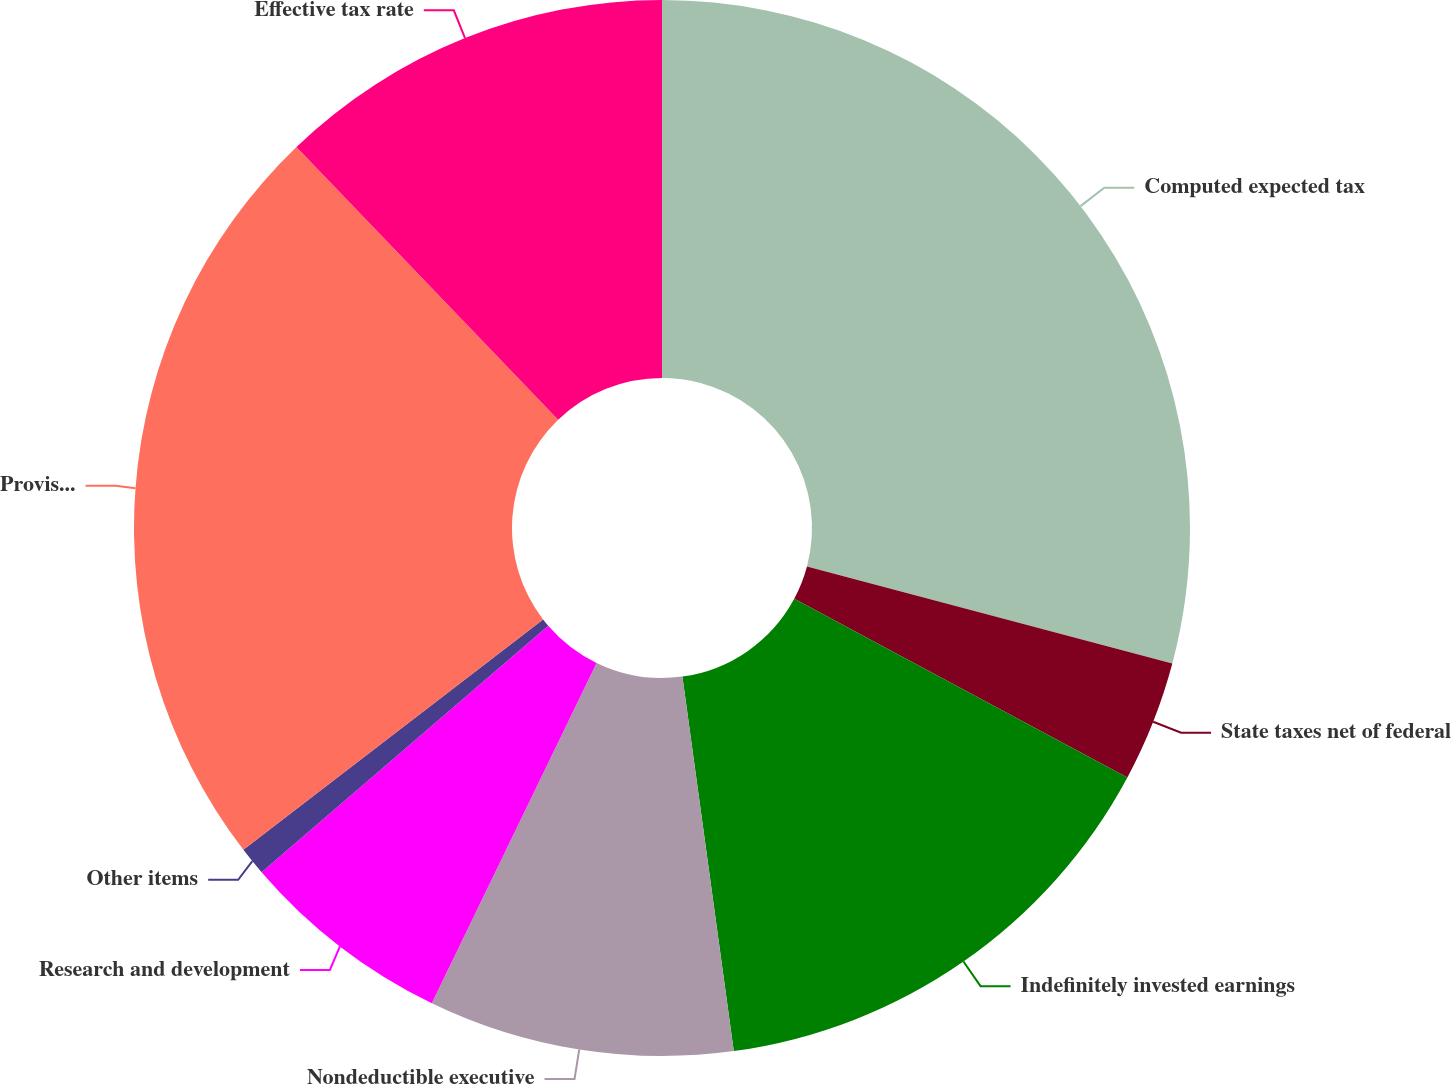Convert chart to OTSL. <chart><loc_0><loc_0><loc_500><loc_500><pie_chart><fcel>Computed expected tax<fcel>State taxes net of federal<fcel>Indefinitely invested earnings<fcel>Nondeductible executive<fcel>Research and development<fcel>Other items<fcel>Provision for income taxes<fcel>Effective tax rate<nl><fcel>29.13%<fcel>3.7%<fcel>15.0%<fcel>9.35%<fcel>6.52%<fcel>0.87%<fcel>23.26%<fcel>12.17%<nl></chart> 